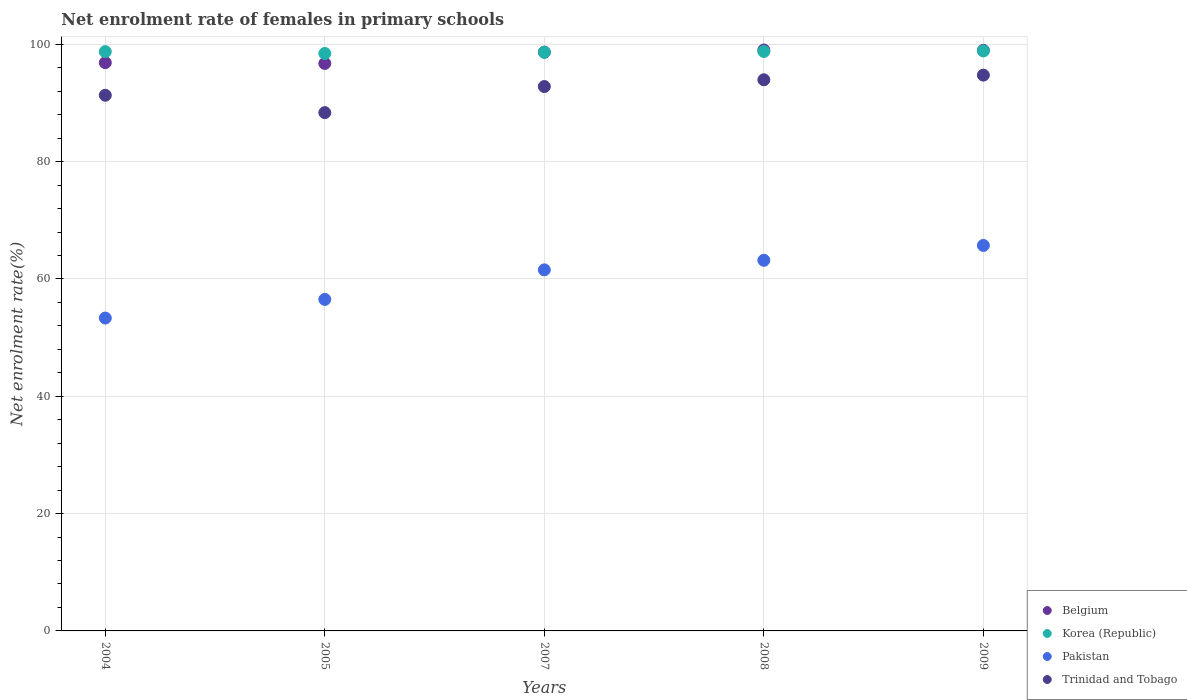How many different coloured dotlines are there?
Provide a succinct answer. 4. What is the net enrolment rate of females in primary schools in Korea (Republic) in 2008?
Ensure brevity in your answer.  98.79. Across all years, what is the maximum net enrolment rate of females in primary schools in Trinidad and Tobago?
Offer a terse response. 94.75. Across all years, what is the minimum net enrolment rate of females in primary schools in Trinidad and Tobago?
Your answer should be compact. 88.36. What is the total net enrolment rate of females in primary schools in Trinidad and Tobago in the graph?
Your response must be concise. 461.21. What is the difference between the net enrolment rate of females in primary schools in Trinidad and Tobago in 2004 and that in 2005?
Give a very brief answer. 2.96. What is the difference between the net enrolment rate of females in primary schools in Pakistan in 2004 and the net enrolment rate of females in primary schools in Belgium in 2009?
Offer a terse response. -45.64. What is the average net enrolment rate of females in primary schools in Korea (Republic) per year?
Ensure brevity in your answer.  98.7. In the year 2007, what is the difference between the net enrolment rate of females in primary schools in Belgium and net enrolment rate of females in primary schools in Trinidad and Tobago?
Provide a short and direct response. 5.86. What is the ratio of the net enrolment rate of females in primary schools in Trinidad and Tobago in 2005 to that in 2007?
Ensure brevity in your answer.  0.95. Is the net enrolment rate of females in primary schools in Korea (Republic) in 2004 less than that in 2008?
Provide a succinct answer. Yes. What is the difference between the highest and the second highest net enrolment rate of females in primary schools in Trinidad and Tobago?
Ensure brevity in your answer.  0.79. What is the difference between the highest and the lowest net enrolment rate of females in primary schools in Pakistan?
Offer a very short reply. 12.38. Is it the case that in every year, the sum of the net enrolment rate of females in primary schools in Pakistan and net enrolment rate of females in primary schools in Trinidad and Tobago  is greater than the sum of net enrolment rate of females in primary schools in Belgium and net enrolment rate of females in primary schools in Korea (Republic)?
Provide a short and direct response. No. Is it the case that in every year, the sum of the net enrolment rate of females in primary schools in Pakistan and net enrolment rate of females in primary schools in Belgium  is greater than the net enrolment rate of females in primary schools in Korea (Republic)?
Ensure brevity in your answer.  Yes. Does the net enrolment rate of females in primary schools in Korea (Republic) monotonically increase over the years?
Keep it short and to the point. No. Is the net enrolment rate of females in primary schools in Belgium strictly greater than the net enrolment rate of females in primary schools in Korea (Republic) over the years?
Keep it short and to the point. No. Is the net enrolment rate of females in primary schools in Pakistan strictly less than the net enrolment rate of females in primary schools in Korea (Republic) over the years?
Provide a succinct answer. Yes. How many dotlines are there?
Your answer should be compact. 4. How many years are there in the graph?
Make the answer very short. 5. What is the difference between two consecutive major ticks on the Y-axis?
Make the answer very short. 20. What is the title of the graph?
Provide a short and direct response. Net enrolment rate of females in primary schools. What is the label or title of the X-axis?
Offer a very short reply. Years. What is the label or title of the Y-axis?
Your answer should be very brief. Net enrolment rate(%). What is the Net enrolment rate(%) of Belgium in 2004?
Provide a short and direct response. 96.88. What is the Net enrolment rate(%) in Korea (Republic) in 2004?
Provide a succinct answer. 98.76. What is the Net enrolment rate(%) of Pakistan in 2004?
Offer a very short reply. 53.34. What is the Net enrolment rate(%) in Trinidad and Tobago in 2004?
Your answer should be very brief. 91.32. What is the Net enrolment rate(%) in Belgium in 2005?
Your answer should be very brief. 96.75. What is the Net enrolment rate(%) of Korea (Republic) in 2005?
Offer a terse response. 98.45. What is the Net enrolment rate(%) in Pakistan in 2005?
Your answer should be very brief. 56.52. What is the Net enrolment rate(%) of Trinidad and Tobago in 2005?
Provide a short and direct response. 88.36. What is the Net enrolment rate(%) in Belgium in 2007?
Your answer should be compact. 98.67. What is the Net enrolment rate(%) of Korea (Republic) in 2007?
Keep it short and to the point. 98.64. What is the Net enrolment rate(%) in Pakistan in 2007?
Provide a short and direct response. 61.56. What is the Net enrolment rate(%) in Trinidad and Tobago in 2007?
Make the answer very short. 92.81. What is the Net enrolment rate(%) in Belgium in 2008?
Provide a short and direct response. 99.04. What is the Net enrolment rate(%) in Korea (Republic) in 2008?
Ensure brevity in your answer.  98.79. What is the Net enrolment rate(%) in Pakistan in 2008?
Provide a short and direct response. 63.19. What is the Net enrolment rate(%) of Trinidad and Tobago in 2008?
Ensure brevity in your answer.  93.96. What is the Net enrolment rate(%) in Belgium in 2009?
Give a very brief answer. 98.98. What is the Net enrolment rate(%) of Korea (Republic) in 2009?
Ensure brevity in your answer.  98.88. What is the Net enrolment rate(%) of Pakistan in 2009?
Offer a very short reply. 65.72. What is the Net enrolment rate(%) of Trinidad and Tobago in 2009?
Your answer should be compact. 94.75. Across all years, what is the maximum Net enrolment rate(%) in Belgium?
Make the answer very short. 99.04. Across all years, what is the maximum Net enrolment rate(%) of Korea (Republic)?
Ensure brevity in your answer.  98.88. Across all years, what is the maximum Net enrolment rate(%) of Pakistan?
Offer a very short reply. 65.72. Across all years, what is the maximum Net enrolment rate(%) in Trinidad and Tobago?
Make the answer very short. 94.75. Across all years, what is the minimum Net enrolment rate(%) of Belgium?
Keep it short and to the point. 96.75. Across all years, what is the minimum Net enrolment rate(%) in Korea (Republic)?
Provide a succinct answer. 98.45. Across all years, what is the minimum Net enrolment rate(%) in Pakistan?
Provide a short and direct response. 53.34. Across all years, what is the minimum Net enrolment rate(%) of Trinidad and Tobago?
Provide a short and direct response. 88.36. What is the total Net enrolment rate(%) in Belgium in the graph?
Provide a short and direct response. 490.32. What is the total Net enrolment rate(%) of Korea (Republic) in the graph?
Make the answer very short. 493.51. What is the total Net enrolment rate(%) of Pakistan in the graph?
Keep it short and to the point. 300.32. What is the total Net enrolment rate(%) of Trinidad and Tobago in the graph?
Provide a short and direct response. 461.21. What is the difference between the Net enrolment rate(%) of Belgium in 2004 and that in 2005?
Make the answer very short. 0.13. What is the difference between the Net enrolment rate(%) in Korea (Republic) in 2004 and that in 2005?
Provide a succinct answer. 0.32. What is the difference between the Net enrolment rate(%) of Pakistan in 2004 and that in 2005?
Provide a succinct answer. -3.18. What is the difference between the Net enrolment rate(%) of Trinidad and Tobago in 2004 and that in 2005?
Offer a very short reply. 2.96. What is the difference between the Net enrolment rate(%) in Belgium in 2004 and that in 2007?
Offer a very short reply. -1.79. What is the difference between the Net enrolment rate(%) in Korea (Republic) in 2004 and that in 2007?
Give a very brief answer. 0.12. What is the difference between the Net enrolment rate(%) of Pakistan in 2004 and that in 2007?
Make the answer very short. -8.22. What is the difference between the Net enrolment rate(%) of Trinidad and Tobago in 2004 and that in 2007?
Offer a very short reply. -1.48. What is the difference between the Net enrolment rate(%) of Belgium in 2004 and that in 2008?
Ensure brevity in your answer.  -2.16. What is the difference between the Net enrolment rate(%) in Korea (Republic) in 2004 and that in 2008?
Provide a succinct answer. -0.02. What is the difference between the Net enrolment rate(%) of Pakistan in 2004 and that in 2008?
Your answer should be compact. -9.85. What is the difference between the Net enrolment rate(%) in Trinidad and Tobago in 2004 and that in 2008?
Make the answer very short. -2.64. What is the difference between the Net enrolment rate(%) in Belgium in 2004 and that in 2009?
Ensure brevity in your answer.  -2.1. What is the difference between the Net enrolment rate(%) in Korea (Republic) in 2004 and that in 2009?
Give a very brief answer. -0.12. What is the difference between the Net enrolment rate(%) of Pakistan in 2004 and that in 2009?
Your response must be concise. -12.38. What is the difference between the Net enrolment rate(%) of Trinidad and Tobago in 2004 and that in 2009?
Your answer should be compact. -3.43. What is the difference between the Net enrolment rate(%) of Belgium in 2005 and that in 2007?
Provide a succinct answer. -1.93. What is the difference between the Net enrolment rate(%) of Korea (Republic) in 2005 and that in 2007?
Keep it short and to the point. -0.2. What is the difference between the Net enrolment rate(%) of Pakistan in 2005 and that in 2007?
Ensure brevity in your answer.  -5.04. What is the difference between the Net enrolment rate(%) in Trinidad and Tobago in 2005 and that in 2007?
Give a very brief answer. -4.45. What is the difference between the Net enrolment rate(%) of Belgium in 2005 and that in 2008?
Your answer should be compact. -2.3. What is the difference between the Net enrolment rate(%) in Korea (Republic) in 2005 and that in 2008?
Provide a succinct answer. -0.34. What is the difference between the Net enrolment rate(%) of Pakistan in 2005 and that in 2008?
Provide a short and direct response. -6.67. What is the difference between the Net enrolment rate(%) in Trinidad and Tobago in 2005 and that in 2008?
Make the answer very short. -5.6. What is the difference between the Net enrolment rate(%) of Belgium in 2005 and that in 2009?
Give a very brief answer. -2.24. What is the difference between the Net enrolment rate(%) of Korea (Republic) in 2005 and that in 2009?
Your answer should be very brief. -0.43. What is the difference between the Net enrolment rate(%) in Pakistan in 2005 and that in 2009?
Offer a terse response. -9.2. What is the difference between the Net enrolment rate(%) of Trinidad and Tobago in 2005 and that in 2009?
Provide a short and direct response. -6.39. What is the difference between the Net enrolment rate(%) in Belgium in 2007 and that in 2008?
Offer a very short reply. -0.37. What is the difference between the Net enrolment rate(%) in Korea (Republic) in 2007 and that in 2008?
Your answer should be compact. -0.14. What is the difference between the Net enrolment rate(%) of Pakistan in 2007 and that in 2008?
Provide a short and direct response. -1.63. What is the difference between the Net enrolment rate(%) of Trinidad and Tobago in 2007 and that in 2008?
Your response must be concise. -1.15. What is the difference between the Net enrolment rate(%) of Belgium in 2007 and that in 2009?
Your answer should be compact. -0.31. What is the difference between the Net enrolment rate(%) in Korea (Republic) in 2007 and that in 2009?
Offer a very short reply. -0.23. What is the difference between the Net enrolment rate(%) in Pakistan in 2007 and that in 2009?
Provide a succinct answer. -4.16. What is the difference between the Net enrolment rate(%) in Trinidad and Tobago in 2007 and that in 2009?
Your answer should be very brief. -1.95. What is the difference between the Net enrolment rate(%) of Belgium in 2008 and that in 2009?
Ensure brevity in your answer.  0.06. What is the difference between the Net enrolment rate(%) of Korea (Republic) in 2008 and that in 2009?
Ensure brevity in your answer.  -0.09. What is the difference between the Net enrolment rate(%) in Pakistan in 2008 and that in 2009?
Keep it short and to the point. -2.53. What is the difference between the Net enrolment rate(%) in Trinidad and Tobago in 2008 and that in 2009?
Offer a very short reply. -0.79. What is the difference between the Net enrolment rate(%) of Belgium in 2004 and the Net enrolment rate(%) of Korea (Republic) in 2005?
Provide a succinct answer. -1.57. What is the difference between the Net enrolment rate(%) in Belgium in 2004 and the Net enrolment rate(%) in Pakistan in 2005?
Give a very brief answer. 40.36. What is the difference between the Net enrolment rate(%) of Belgium in 2004 and the Net enrolment rate(%) of Trinidad and Tobago in 2005?
Your answer should be very brief. 8.52. What is the difference between the Net enrolment rate(%) of Korea (Republic) in 2004 and the Net enrolment rate(%) of Pakistan in 2005?
Ensure brevity in your answer.  42.24. What is the difference between the Net enrolment rate(%) in Korea (Republic) in 2004 and the Net enrolment rate(%) in Trinidad and Tobago in 2005?
Your answer should be compact. 10.4. What is the difference between the Net enrolment rate(%) in Pakistan in 2004 and the Net enrolment rate(%) in Trinidad and Tobago in 2005?
Your response must be concise. -35.02. What is the difference between the Net enrolment rate(%) in Belgium in 2004 and the Net enrolment rate(%) in Korea (Republic) in 2007?
Keep it short and to the point. -1.76. What is the difference between the Net enrolment rate(%) in Belgium in 2004 and the Net enrolment rate(%) in Pakistan in 2007?
Your answer should be compact. 35.32. What is the difference between the Net enrolment rate(%) of Belgium in 2004 and the Net enrolment rate(%) of Trinidad and Tobago in 2007?
Your answer should be compact. 4.07. What is the difference between the Net enrolment rate(%) of Korea (Republic) in 2004 and the Net enrolment rate(%) of Pakistan in 2007?
Provide a short and direct response. 37.2. What is the difference between the Net enrolment rate(%) of Korea (Republic) in 2004 and the Net enrolment rate(%) of Trinidad and Tobago in 2007?
Offer a terse response. 5.95. What is the difference between the Net enrolment rate(%) of Pakistan in 2004 and the Net enrolment rate(%) of Trinidad and Tobago in 2007?
Ensure brevity in your answer.  -39.47. What is the difference between the Net enrolment rate(%) in Belgium in 2004 and the Net enrolment rate(%) in Korea (Republic) in 2008?
Offer a terse response. -1.91. What is the difference between the Net enrolment rate(%) of Belgium in 2004 and the Net enrolment rate(%) of Pakistan in 2008?
Offer a very short reply. 33.69. What is the difference between the Net enrolment rate(%) in Belgium in 2004 and the Net enrolment rate(%) in Trinidad and Tobago in 2008?
Offer a very short reply. 2.92. What is the difference between the Net enrolment rate(%) of Korea (Republic) in 2004 and the Net enrolment rate(%) of Pakistan in 2008?
Offer a terse response. 35.57. What is the difference between the Net enrolment rate(%) in Korea (Republic) in 2004 and the Net enrolment rate(%) in Trinidad and Tobago in 2008?
Offer a very short reply. 4.8. What is the difference between the Net enrolment rate(%) in Pakistan in 2004 and the Net enrolment rate(%) in Trinidad and Tobago in 2008?
Keep it short and to the point. -40.62. What is the difference between the Net enrolment rate(%) of Belgium in 2004 and the Net enrolment rate(%) of Korea (Republic) in 2009?
Provide a short and direct response. -2. What is the difference between the Net enrolment rate(%) of Belgium in 2004 and the Net enrolment rate(%) of Pakistan in 2009?
Keep it short and to the point. 31.16. What is the difference between the Net enrolment rate(%) of Belgium in 2004 and the Net enrolment rate(%) of Trinidad and Tobago in 2009?
Make the answer very short. 2.13. What is the difference between the Net enrolment rate(%) of Korea (Republic) in 2004 and the Net enrolment rate(%) of Pakistan in 2009?
Keep it short and to the point. 33.04. What is the difference between the Net enrolment rate(%) of Korea (Republic) in 2004 and the Net enrolment rate(%) of Trinidad and Tobago in 2009?
Offer a very short reply. 4.01. What is the difference between the Net enrolment rate(%) of Pakistan in 2004 and the Net enrolment rate(%) of Trinidad and Tobago in 2009?
Give a very brief answer. -41.41. What is the difference between the Net enrolment rate(%) of Belgium in 2005 and the Net enrolment rate(%) of Korea (Republic) in 2007?
Give a very brief answer. -1.9. What is the difference between the Net enrolment rate(%) of Belgium in 2005 and the Net enrolment rate(%) of Pakistan in 2007?
Offer a very short reply. 35.19. What is the difference between the Net enrolment rate(%) of Belgium in 2005 and the Net enrolment rate(%) of Trinidad and Tobago in 2007?
Your answer should be very brief. 3.94. What is the difference between the Net enrolment rate(%) in Korea (Republic) in 2005 and the Net enrolment rate(%) in Pakistan in 2007?
Your answer should be very brief. 36.89. What is the difference between the Net enrolment rate(%) of Korea (Republic) in 2005 and the Net enrolment rate(%) of Trinidad and Tobago in 2007?
Ensure brevity in your answer.  5.64. What is the difference between the Net enrolment rate(%) in Pakistan in 2005 and the Net enrolment rate(%) in Trinidad and Tobago in 2007?
Your response must be concise. -36.29. What is the difference between the Net enrolment rate(%) of Belgium in 2005 and the Net enrolment rate(%) of Korea (Republic) in 2008?
Ensure brevity in your answer.  -2.04. What is the difference between the Net enrolment rate(%) of Belgium in 2005 and the Net enrolment rate(%) of Pakistan in 2008?
Your answer should be very brief. 33.56. What is the difference between the Net enrolment rate(%) of Belgium in 2005 and the Net enrolment rate(%) of Trinidad and Tobago in 2008?
Ensure brevity in your answer.  2.78. What is the difference between the Net enrolment rate(%) in Korea (Republic) in 2005 and the Net enrolment rate(%) in Pakistan in 2008?
Make the answer very short. 35.26. What is the difference between the Net enrolment rate(%) of Korea (Republic) in 2005 and the Net enrolment rate(%) of Trinidad and Tobago in 2008?
Make the answer very short. 4.48. What is the difference between the Net enrolment rate(%) in Pakistan in 2005 and the Net enrolment rate(%) in Trinidad and Tobago in 2008?
Ensure brevity in your answer.  -37.44. What is the difference between the Net enrolment rate(%) in Belgium in 2005 and the Net enrolment rate(%) in Korea (Republic) in 2009?
Provide a short and direct response. -2.13. What is the difference between the Net enrolment rate(%) of Belgium in 2005 and the Net enrolment rate(%) of Pakistan in 2009?
Make the answer very short. 31.03. What is the difference between the Net enrolment rate(%) in Belgium in 2005 and the Net enrolment rate(%) in Trinidad and Tobago in 2009?
Your answer should be very brief. 1.99. What is the difference between the Net enrolment rate(%) of Korea (Republic) in 2005 and the Net enrolment rate(%) of Pakistan in 2009?
Keep it short and to the point. 32.73. What is the difference between the Net enrolment rate(%) in Korea (Republic) in 2005 and the Net enrolment rate(%) in Trinidad and Tobago in 2009?
Keep it short and to the point. 3.69. What is the difference between the Net enrolment rate(%) of Pakistan in 2005 and the Net enrolment rate(%) of Trinidad and Tobago in 2009?
Ensure brevity in your answer.  -38.24. What is the difference between the Net enrolment rate(%) in Belgium in 2007 and the Net enrolment rate(%) in Korea (Republic) in 2008?
Ensure brevity in your answer.  -0.11. What is the difference between the Net enrolment rate(%) of Belgium in 2007 and the Net enrolment rate(%) of Pakistan in 2008?
Offer a terse response. 35.49. What is the difference between the Net enrolment rate(%) of Belgium in 2007 and the Net enrolment rate(%) of Trinidad and Tobago in 2008?
Offer a very short reply. 4.71. What is the difference between the Net enrolment rate(%) in Korea (Republic) in 2007 and the Net enrolment rate(%) in Pakistan in 2008?
Offer a terse response. 35.46. What is the difference between the Net enrolment rate(%) of Korea (Republic) in 2007 and the Net enrolment rate(%) of Trinidad and Tobago in 2008?
Provide a succinct answer. 4.68. What is the difference between the Net enrolment rate(%) of Pakistan in 2007 and the Net enrolment rate(%) of Trinidad and Tobago in 2008?
Provide a succinct answer. -32.41. What is the difference between the Net enrolment rate(%) of Belgium in 2007 and the Net enrolment rate(%) of Korea (Republic) in 2009?
Ensure brevity in your answer.  -0.21. What is the difference between the Net enrolment rate(%) of Belgium in 2007 and the Net enrolment rate(%) of Pakistan in 2009?
Keep it short and to the point. 32.95. What is the difference between the Net enrolment rate(%) of Belgium in 2007 and the Net enrolment rate(%) of Trinidad and Tobago in 2009?
Keep it short and to the point. 3.92. What is the difference between the Net enrolment rate(%) of Korea (Republic) in 2007 and the Net enrolment rate(%) of Pakistan in 2009?
Make the answer very short. 32.92. What is the difference between the Net enrolment rate(%) in Korea (Republic) in 2007 and the Net enrolment rate(%) in Trinidad and Tobago in 2009?
Your answer should be very brief. 3.89. What is the difference between the Net enrolment rate(%) of Pakistan in 2007 and the Net enrolment rate(%) of Trinidad and Tobago in 2009?
Your answer should be very brief. -33.2. What is the difference between the Net enrolment rate(%) in Belgium in 2008 and the Net enrolment rate(%) in Korea (Republic) in 2009?
Your answer should be compact. 0.16. What is the difference between the Net enrolment rate(%) in Belgium in 2008 and the Net enrolment rate(%) in Pakistan in 2009?
Your answer should be compact. 33.32. What is the difference between the Net enrolment rate(%) of Belgium in 2008 and the Net enrolment rate(%) of Trinidad and Tobago in 2009?
Offer a very short reply. 4.29. What is the difference between the Net enrolment rate(%) of Korea (Republic) in 2008 and the Net enrolment rate(%) of Pakistan in 2009?
Offer a very short reply. 33.07. What is the difference between the Net enrolment rate(%) of Korea (Republic) in 2008 and the Net enrolment rate(%) of Trinidad and Tobago in 2009?
Offer a very short reply. 4.03. What is the difference between the Net enrolment rate(%) in Pakistan in 2008 and the Net enrolment rate(%) in Trinidad and Tobago in 2009?
Offer a very short reply. -31.57. What is the average Net enrolment rate(%) in Belgium per year?
Your answer should be very brief. 98.06. What is the average Net enrolment rate(%) of Korea (Republic) per year?
Your answer should be compact. 98.7. What is the average Net enrolment rate(%) of Pakistan per year?
Give a very brief answer. 60.06. What is the average Net enrolment rate(%) in Trinidad and Tobago per year?
Your answer should be compact. 92.24. In the year 2004, what is the difference between the Net enrolment rate(%) in Belgium and Net enrolment rate(%) in Korea (Republic)?
Your answer should be compact. -1.88. In the year 2004, what is the difference between the Net enrolment rate(%) of Belgium and Net enrolment rate(%) of Pakistan?
Ensure brevity in your answer.  43.54. In the year 2004, what is the difference between the Net enrolment rate(%) in Belgium and Net enrolment rate(%) in Trinidad and Tobago?
Your answer should be compact. 5.56. In the year 2004, what is the difference between the Net enrolment rate(%) in Korea (Republic) and Net enrolment rate(%) in Pakistan?
Your response must be concise. 45.42. In the year 2004, what is the difference between the Net enrolment rate(%) of Korea (Republic) and Net enrolment rate(%) of Trinidad and Tobago?
Offer a very short reply. 7.44. In the year 2004, what is the difference between the Net enrolment rate(%) in Pakistan and Net enrolment rate(%) in Trinidad and Tobago?
Provide a succinct answer. -37.98. In the year 2005, what is the difference between the Net enrolment rate(%) of Belgium and Net enrolment rate(%) of Korea (Republic)?
Provide a short and direct response. -1.7. In the year 2005, what is the difference between the Net enrolment rate(%) of Belgium and Net enrolment rate(%) of Pakistan?
Offer a terse response. 40.23. In the year 2005, what is the difference between the Net enrolment rate(%) of Belgium and Net enrolment rate(%) of Trinidad and Tobago?
Your answer should be very brief. 8.39. In the year 2005, what is the difference between the Net enrolment rate(%) of Korea (Republic) and Net enrolment rate(%) of Pakistan?
Make the answer very short. 41.93. In the year 2005, what is the difference between the Net enrolment rate(%) in Korea (Republic) and Net enrolment rate(%) in Trinidad and Tobago?
Offer a terse response. 10.09. In the year 2005, what is the difference between the Net enrolment rate(%) of Pakistan and Net enrolment rate(%) of Trinidad and Tobago?
Your response must be concise. -31.84. In the year 2007, what is the difference between the Net enrolment rate(%) of Belgium and Net enrolment rate(%) of Korea (Republic)?
Your answer should be very brief. 0.03. In the year 2007, what is the difference between the Net enrolment rate(%) of Belgium and Net enrolment rate(%) of Pakistan?
Your response must be concise. 37.12. In the year 2007, what is the difference between the Net enrolment rate(%) in Belgium and Net enrolment rate(%) in Trinidad and Tobago?
Keep it short and to the point. 5.86. In the year 2007, what is the difference between the Net enrolment rate(%) of Korea (Republic) and Net enrolment rate(%) of Pakistan?
Your answer should be compact. 37.09. In the year 2007, what is the difference between the Net enrolment rate(%) in Korea (Republic) and Net enrolment rate(%) in Trinidad and Tobago?
Your answer should be very brief. 5.84. In the year 2007, what is the difference between the Net enrolment rate(%) of Pakistan and Net enrolment rate(%) of Trinidad and Tobago?
Offer a terse response. -31.25. In the year 2008, what is the difference between the Net enrolment rate(%) of Belgium and Net enrolment rate(%) of Korea (Republic)?
Offer a very short reply. 0.26. In the year 2008, what is the difference between the Net enrolment rate(%) of Belgium and Net enrolment rate(%) of Pakistan?
Your response must be concise. 35.86. In the year 2008, what is the difference between the Net enrolment rate(%) in Belgium and Net enrolment rate(%) in Trinidad and Tobago?
Your response must be concise. 5.08. In the year 2008, what is the difference between the Net enrolment rate(%) in Korea (Republic) and Net enrolment rate(%) in Pakistan?
Provide a short and direct response. 35.6. In the year 2008, what is the difference between the Net enrolment rate(%) in Korea (Republic) and Net enrolment rate(%) in Trinidad and Tobago?
Keep it short and to the point. 4.82. In the year 2008, what is the difference between the Net enrolment rate(%) of Pakistan and Net enrolment rate(%) of Trinidad and Tobago?
Your response must be concise. -30.78. In the year 2009, what is the difference between the Net enrolment rate(%) in Belgium and Net enrolment rate(%) in Korea (Republic)?
Your answer should be compact. 0.11. In the year 2009, what is the difference between the Net enrolment rate(%) in Belgium and Net enrolment rate(%) in Pakistan?
Make the answer very short. 33.26. In the year 2009, what is the difference between the Net enrolment rate(%) in Belgium and Net enrolment rate(%) in Trinidad and Tobago?
Offer a terse response. 4.23. In the year 2009, what is the difference between the Net enrolment rate(%) in Korea (Republic) and Net enrolment rate(%) in Pakistan?
Your response must be concise. 33.16. In the year 2009, what is the difference between the Net enrolment rate(%) of Korea (Republic) and Net enrolment rate(%) of Trinidad and Tobago?
Offer a terse response. 4.12. In the year 2009, what is the difference between the Net enrolment rate(%) of Pakistan and Net enrolment rate(%) of Trinidad and Tobago?
Make the answer very short. -29.03. What is the ratio of the Net enrolment rate(%) in Korea (Republic) in 2004 to that in 2005?
Offer a very short reply. 1. What is the ratio of the Net enrolment rate(%) in Pakistan in 2004 to that in 2005?
Give a very brief answer. 0.94. What is the ratio of the Net enrolment rate(%) of Trinidad and Tobago in 2004 to that in 2005?
Offer a very short reply. 1.03. What is the ratio of the Net enrolment rate(%) in Belgium in 2004 to that in 2007?
Provide a succinct answer. 0.98. What is the ratio of the Net enrolment rate(%) of Korea (Republic) in 2004 to that in 2007?
Make the answer very short. 1. What is the ratio of the Net enrolment rate(%) of Pakistan in 2004 to that in 2007?
Ensure brevity in your answer.  0.87. What is the ratio of the Net enrolment rate(%) in Trinidad and Tobago in 2004 to that in 2007?
Ensure brevity in your answer.  0.98. What is the ratio of the Net enrolment rate(%) in Belgium in 2004 to that in 2008?
Provide a short and direct response. 0.98. What is the ratio of the Net enrolment rate(%) of Pakistan in 2004 to that in 2008?
Ensure brevity in your answer.  0.84. What is the ratio of the Net enrolment rate(%) of Trinidad and Tobago in 2004 to that in 2008?
Your answer should be very brief. 0.97. What is the ratio of the Net enrolment rate(%) in Belgium in 2004 to that in 2009?
Offer a terse response. 0.98. What is the ratio of the Net enrolment rate(%) in Korea (Republic) in 2004 to that in 2009?
Offer a terse response. 1. What is the ratio of the Net enrolment rate(%) in Pakistan in 2004 to that in 2009?
Offer a very short reply. 0.81. What is the ratio of the Net enrolment rate(%) of Trinidad and Tobago in 2004 to that in 2009?
Offer a very short reply. 0.96. What is the ratio of the Net enrolment rate(%) in Belgium in 2005 to that in 2007?
Offer a very short reply. 0.98. What is the ratio of the Net enrolment rate(%) of Pakistan in 2005 to that in 2007?
Make the answer very short. 0.92. What is the ratio of the Net enrolment rate(%) of Trinidad and Tobago in 2005 to that in 2007?
Offer a very short reply. 0.95. What is the ratio of the Net enrolment rate(%) in Belgium in 2005 to that in 2008?
Give a very brief answer. 0.98. What is the ratio of the Net enrolment rate(%) in Korea (Republic) in 2005 to that in 2008?
Your response must be concise. 1. What is the ratio of the Net enrolment rate(%) of Pakistan in 2005 to that in 2008?
Give a very brief answer. 0.89. What is the ratio of the Net enrolment rate(%) of Trinidad and Tobago in 2005 to that in 2008?
Give a very brief answer. 0.94. What is the ratio of the Net enrolment rate(%) in Belgium in 2005 to that in 2009?
Make the answer very short. 0.98. What is the ratio of the Net enrolment rate(%) in Pakistan in 2005 to that in 2009?
Offer a very short reply. 0.86. What is the ratio of the Net enrolment rate(%) of Trinidad and Tobago in 2005 to that in 2009?
Keep it short and to the point. 0.93. What is the ratio of the Net enrolment rate(%) in Belgium in 2007 to that in 2008?
Provide a short and direct response. 1. What is the ratio of the Net enrolment rate(%) of Pakistan in 2007 to that in 2008?
Give a very brief answer. 0.97. What is the ratio of the Net enrolment rate(%) of Trinidad and Tobago in 2007 to that in 2008?
Ensure brevity in your answer.  0.99. What is the ratio of the Net enrolment rate(%) in Belgium in 2007 to that in 2009?
Keep it short and to the point. 1. What is the ratio of the Net enrolment rate(%) of Korea (Republic) in 2007 to that in 2009?
Provide a succinct answer. 1. What is the ratio of the Net enrolment rate(%) in Pakistan in 2007 to that in 2009?
Provide a short and direct response. 0.94. What is the ratio of the Net enrolment rate(%) of Trinidad and Tobago in 2007 to that in 2009?
Make the answer very short. 0.98. What is the ratio of the Net enrolment rate(%) in Belgium in 2008 to that in 2009?
Ensure brevity in your answer.  1. What is the ratio of the Net enrolment rate(%) of Pakistan in 2008 to that in 2009?
Offer a terse response. 0.96. What is the difference between the highest and the second highest Net enrolment rate(%) of Belgium?
Give a very brief answer. 0.06. What is the difference between the highest and the second highest Net enrolment rate(%) of Korea (Republic)?
Make the answer very short. 0.09. What is the difference between the highest and the second highest Net enrolment rate(%) in Pakistan?
Your answer should be compact. 2.53. What is the difference between the highest and the second highest Net enrolment rate(%) of Trinidad and Tobago?
Offer a terse response. 0.79. What is the difference between the highest and the lowest Net enrolment rate(%) in Belgium?
Provide a short and direct response. 2.3. What is the difference between the highest and the lowest Net enrolment rate(%) of Korea (Republic)?
Offer a terse response. 0.43. What is the difference between the highest and the lowest Net enrolment rate(%) in Pakistan?
Provide a succinct answer. 12.38. What is the difference between the highest and the lowest Net enrolment rate(%) in Trinidad and Tobago?
Make the answer very short. 6.39. 